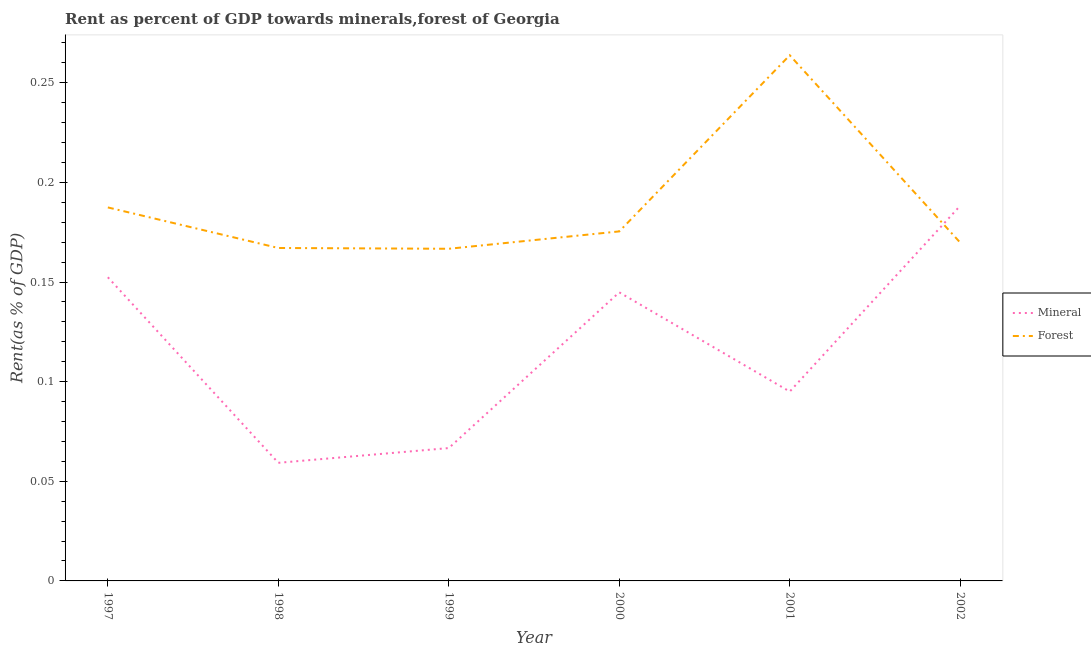Does the line corresponding to forest rent intersect with the line corresponding to mineral rent?
Keep it short and to the point. Yes. What is the mineral rent in 1997?
Provide a short and direct response. 0.15. Across all years, what is the maximum mineral rent?
Make the answer very short. 0.19. Across all years, what is the minimum forest rent?
Offer a terse response. 0.17. In which year was the forest rent maximum?
Give a very brief answer. 2001. In which year was the mineral rent minimum?
Provide a short and direct response. 1998. What is the total forest rent in the graph?
Your answer should be compact. 1.13. What is the difference between the mineral rent in 1997 and that in 2002?
Ensure brevity in your answer.  -0.04. What is the difference between the mineral rent in 1997 and the forest rent in 2000?
Offer a terse response. -0.02. What is the average mineral rent per year?
Your response must be concise. 0.12. In the year 1999, what is the difference between the mineral rent and forest rent?
Your response must be concise. -0.1. What is the ratio of the forest rent in 1999 to that in 2000?
Keep it short and to the point. 0.95. Is the difference between the mineral rent in 1997 and 2001 greater than the difference between the forest rent in 1997 and 2001?
Offer a terse response. Yes. What is the difference between the highest and the second highest forest rent?
Offer a terse response. 0.08. What is the difference between the highest and the lowest forest rent?
Provide a short and direct response. 0.1. Is the sum of the mineral rent in 1998 and 1999 greater than the maximum forest rent across all years?
Offer a terse response. No. Does the mineral rent monotonically increase over the years?
Provide a short and direct response. No. What is the difference between two consecutive major ticks on the Y-axis?
Your answer should be compact. 0.05. Are the values on the major ticks of Y-axis written in scientific E-notation?
Your response must be concise. No. Where does the legend appear in the graph?
Ensure brevity in your answer.  Center right. How are the legend labels stacked?
Your answer should be very brief. Vertical. What is the title of the graph?
Ensure brevity in your answer.  Rent as percent of GDP towards minerals,forest of Georgia. What is the label or title of the Y-axis?
Provide a short and direct response. Rent(as % of GDP). What is the Rent(as % of GDP) in Mineral in 1997?
Keep it short and to the point. 0.15. What is the Rent(as % of GDP) of Forest in 1997?
Make the answer very short. 0.19. What is the Rent(as % of GDP) of Mineral in 1998?
Your response must be concise. 0.06. What is the Rent(as % of GDP) of Forest in 1998?
Offer a terse response. 0.17. What is the Rent(as % of GDP) in Mineral in 1999?
Provide a succinct answer. 0.07. What is the Rent(as % of GDP) of Forest in 1999?
Your response must be concise. 0.17. What is the Rent(as % of GDP) of Mineral in 2000?
Offer a very short reply. 0.14. What is the Rent(as % of GDP) in Forest in 2000?
Your response must be concise. 0.18. What is the Rent(as % of GDP) of Mineral in 2001?
Give a very brief answer. 0.1. What is the Rent(as % of GDP) in Forest in 2001?
Give a very brief answer. 0.26. What is the Rent(as % of GDP) in Mineral in 2002?
Ensure brevity in your answer.  0.19. What is the Rent(as % of GDP) in Forest in 2002?
Keep it short and to the point. 0.17. Across all years, what is the maximum Rent(as % of GDP) of Mineral?
Give a very brief answer. 0.19. Across all years, what is the maximum Rent(as % of GDP) in Forest?
Offer a terse response. 0.26. Across all years, what is the minimum Rent(as % of GDP) of Mineral?
Make the answer very short. 0.06. Across all years, what is the minimum Rent(as % of GDP) in Forest?
Offer a terse response. 0.17. What is the total Rent(as % of GDP) in Mineral in the graph?
Your answer should be compact. 0.71. What is the total Rent(as % of GDP) of Forest in the graph?
Provide a short and direct response. 1.13. What is the difference between the Rent(as % of GDP) of Mineral in 1997 and that in 1998?
Provide a succinct answer. 0.09. What is the difference between the Rent(as % of GDP) in Forest in 1997 and that in 1998?
Your answer should be compact. 0.02. What is the difference between the Rent(as % of GDP) in Mineral in 1997 and that in 1999?
Your answer should be very brief. 0.09. What is the difference between the Rent(as % of GDP) in Forest in 1997 and that in 1999?
Provide a succinct answer. 0.02. What is the difference between the Rent(as % of GDP) of Mineral in 1997 and that in 2000?
Provide a short and direct response. 0.01. What is the difference between the Rent(as % of GDP) in Forest in 1997 and that in 2000?
Ensure brevity in your answer.  0.01. What is the difference between the Rent(as % of GDP) of Mineral in 1997 and that in 2001?
Provide a short and direct response. 0.06. What is the difference between the Rent(as % of GDP) in Forest in 1997 and that in 2001?
Offer a very short reply. -0.08. What is the difference between the Rent(as % of GDP) in Mineral in 1997 and that in 2002?
Your answer should be very brief. -0.04. What is the difference between the Rent(as % of GDP) of Forest in 1997 and that in 2002?
Provide a succinct answer. 0.02. What is the difference between the Rent(as % of GDP) in Mineral in 1998 and that in 1999?
Ensure brevity in your answer.  -0.01. What is the difference between the Rent(as % of GDP) of Mineral in 1998 and that in 2000?
Provide a short and direct response. -0.09. What is the difference between the Rent(as % of GDP) of Forest in 1998 and that in 2000?
Ensure brevity in your answer.  -0.01. What is the difference between the Rent(as % of GDP) in Mineral in 1998 and that in 2001?
Your answer should be very brief. -0.04. What is the difference between the Rent(as % of GDP) in Forest in 1998 and that in 2001?
Provide a succinct answer. -0.1. What is the difference between the Rent(as % of GDP) of Mineral in 1998 and that in 2002?
Offer a terse response. -0.13. What is the difference between the Rent(as % of GDP) of Forest in 1998 and that in 2002?
Your answer should be compact. -0. What is the difference between the Rent(as % of GDP) of Mineral in 1999 and that in 2000?
Ensure brevity in your answer.  -0.08. What is the difference between the Rent(as % of GDP) of Forest in 1999 and that in 2000?
Provide a succinct answer. -0.01. What is the difference between the Rent(as % of GDP) in Mineral in 1999 and that in 2001?
Make the answer very short. -0.03. What is the difference between the Rent(as % of GDP) in Forest in 1999 and that in 2001?
Your answer should be very brief. -0.1. What is the difference between the Rent(as % of GDP) in Mineral in 1999 and that in 2002?
Provide a short and direct response. -0.12. What is the difference between the Rent(as % of GDP) of Forest in 1999 and that in 2002?
Keep it short and to the point. -0. What is the difference between the Rent(as % of GDP) in Mineral in 2000 and that in 2001?
Provide a succinct answer. 0.05. What is the difference between the Rent(as % of GDP) of Forest in 2000 and that in 2001?
Your response must be concise. -0.09. What is the difference between the Rent(as % of GDP) of Mineral in 2000 and that in 2002?
Give a very brief answer. -0.04. What is the difference between the Rent(as % of GDP) in Forest in 2000 and that in 2002?
Provide a short and direct response. 0.01. What is the difference between the Rent(as % of GDP) in Mineral in 2001 and that in 2002?
Provide a succinct answer. -0.09. What is the difference between the Rent(as % of GDP) of Forest in 2001 and that in 2002?
Keep it short and to the point. 0.09. What is the difference between the Rent(as % of GDP) in Mineral in 1997 and the Rent(as % of GDP) in Forest in 1998?
Make the answer very short. -0.01. What is the difference between the Rent(as % of GDP) of Mineral in 1997 and the Rent(as % of GDP) of Forest in 1999?
Make the answer very short. -0.01. What is the difference between the Rent(as % of GDP) of Mineral in 1997 and the Rent(as % of GDP) of Forest in 2000?
Offer a very short reply. -0.02. What is the difference between the Rent(as % of GDP) in Mineral in 1997 and the Rent(as % of GDP) in Forest in 2001?
Provide a succinct answer. -0.11. What is the difference between the Rent(as % of GDP) of Mineral in 1997 and the Rent(as % of GDP) of Forest in 2002?
Give a very brief answer. -0.02. What is the difference between the Rent(as % of GDP) in Mineral in 1998 and the Rent(as % of GDP) in Forest in 1999?
Keep it short and to the point. -0.11. What is the difference between the Rent(as % of GDP) in Mineral in 1998 and the Rent(as % of GDP) in Forest in 2000?
Make the answer very short. -0.12. What is the difference between the Rent(as % of GDP) in Mineral in 1998 and the Rent(as % of GDP) in Forest in 2001?
Offer a very short reply. -0.2. What is the difference between the Rent(as % of GDP) of Mineral in 1998 and the Rent(as % of GDP) of Forest in 2002?
Your response must be concise. -0.11. What is the difference between the Rent(as % of GDP) of Mineral in 1999 and the Rent(as % of GDP) of Forest in 2000?
Ensure brevity in your answer.  -0.11. What is the difference between the Rent(as % of GDP) in Mineral in 1999 and the Rent(as % of GDP) in Forest in 2001?
Your answer should be very brief. -0.2. What is the difference between the Rent(as % of GDP) of Mineral in 1999 and the Rent(as % of GDP) of Forest in 2002?
Provide a short and direct response. -0.1. What is the difference between the Rent(as % of GDP) in Mineral in 2000 and the Rent(as % of GDP) in Forest in 2001?
Your response must be concise. -0.12. What is the difference between the Rent(as % of GDP) of Mineral in 2000 and the Rent(as % of GDP) of Forest in 2002?
Your response must be concise. -0.02. What is the difference between the Rent(as % of GDP) in Mineral in 2001 and the Rent(as % of GDP) in Forest in 2002?
Your response must be concise. -0.07. What is the average Rent(as % of GDP) in Mineral per year?
Provide a short and direct response. 0.12. What is the average Rent(as % of GDP) of Forest per year?
Your answer should be very brief. 0.19. In the year 1997, what is the difference between the Rent(as % of GDP) of Mineral and Rent(as % of GDP) of Forest?
Offer a very short reply. -0.04. In the year 1998, what is the difference between the Rent(as % of GDP) in Mineral and Rent(as % of GDP) in Forest?
Provide a succinct answer. -0.11. In the year 2000, what is the difference between the Rent(as % of GDP) in Mineral and Rent(as % of GDP) in Forest?
Provide a short and direct response. -0.03. In the year 2001, what is the difference between the Rent(as % of GDP) of Mineral and Rent(as % of GDP) of Forest?
Your answer should be very brief. -0.17. In the year 2002, what is the difference between the Rent(as % of GDP) in Mineral and Rent(as % of GDP) in Forest?
Provide a succinct answer. 0.02. What is the ratio of the Rent(as % of GDP) of Mineral in 1997 to that in 1998?
Your response must be concise. 2.57. What is the ratio of the Rent(as % of GDP) of Forest in 1997 to that in 1998?
Your answer should be compact. 1.12. What is the ratio of the Rent(as % of GDP) in Mineral in 1997 to that in 1999?
Make the answer very short. 2.29. What is the ratio of the Rent(as % of GDP) in Forest in 1997 to that in 1999?
Keep it short and to the point. 1.12. What is the ratio of the Rent(as % of GDP) in Mineral in 1997 to that in 2000?
Your answer should be very brief. 1.05. What is the ratio of the Rent(as % of GDP) of Forest in 1997 to that in 2000?
Ensure brevity in your answer.  1.07. What is the ratio of the Rent(as % of GDP) of Mineral in 1997 to that in 2001?
Provide a succinct answer. 1.6. What is the ratio of the Rent(as % of GDP) in Forest in 1997 to that in 2001?
Make the answer very short. 0.71. What is the ratio of the Rent(as % of GDP) in Mineral in 1997 to that in 2002?
Your response must be concise. 0.81. What is the ratio of the Rent(as % of GDP) of Forest in 1997 to that in 2002?
Offer a terse response. 1.1. What is the ratio of the Rent(as % of GDP) of Mineral in 1998 to that in 1999?
Make the answer very short. 0.89. What is the ratio of the Rent(as % of GDP) in Mineral in 1998 to that in 2000?
Ensure brevity in your answer.  0.41. What is the ratio of the Rent(as % of GDP) in Forest in 1998 to that in 2000?
Your response must be concise. 0.95. What is the ratio of the Rent(as % of GDP) of Mineral in 1998 to that in 2001?
Ensure brevity in your answer.  0.62. What is the ratio of the Rent(as % of GDP) of Forest in 1998 to that in 2001?
Offer a very short reply. 0.63. What is the ratio of the Rent(as % of GDP) in Mineral in 1998 to that in 2002?
Provide a succinct answer. 0.31. What is the ratio of the Rent(as % of GDP) of Forest in 1998 to that in 2002?
Make the answer very short. 0.98. What is the ratio of the Rent(as % of GDP) in Mineral in 1999 to that in 2000?
Offer a very short reply. 0.46. What is the ratio of the Rent(as % of GDP) in Forest in 1999 to that in 2000?
Offer a terse response. 0.95. What is the ratio of the Rent(as % of GDP) of Mineral in 1999 to that in 2001?
Keep it short and to the point. 0.7. What is the ratio of the Rent(as % of GDP) in Forest in 1999 to that in 2001?
Keep it short and to the point. 0.63. What is the ratio of the Rent(as % of GDP) of Mineral in 1999 to that in 2002?
Give a very brief answer. 0.35. What is the ratio of the Rent(as % of GDP) in Forest in 1999 to that in 2002?
Make the answer very short. 0.98. What is the ratio of the Rent(as % of GDP) of Mineral in 2000 to that in 2001?
Ensure brevity in your answer.  1.52. What is the ratio of the Rent(as % of GDP) of Forest in 2000 to that in 2001?
Your answer should be very brief. 0.66. What is the ratio of the Rent(as % of GDP) in Mineral in 2000 to that in 2002?
Your answer should be compact. 0.77. What is the ratio of the Rent(as % of GDP) in Forest in 2000 to that in 2002?
Give a very brief answer. 1.03. What is the ratio of the Rent(as % of GDP) of Mineral in 2001 to that in 2002?
Offer a very short reply. 0.5. What is the ratio of the Rent(as % of GDP) in Forest in 2001 to that in 2002?
Provide a succinct answer. 1.55. What is the difference between the highest and the second highest Rent(as % of GDP) in Mineral?
Your response must be concise. 0.04. What is the difference between the highest and the second highest Rent(as % of GDP) of Forest?
Your answer should be very brief. 0.08. What is the difference between the highest and the lowest Rent(as % of GDP) in Mineral?
Make the answer very short. 0.13. What is the difference between the highest and the lowest Rent(as % of GDP) in Forest?
Your response must be concise. 0.1. 